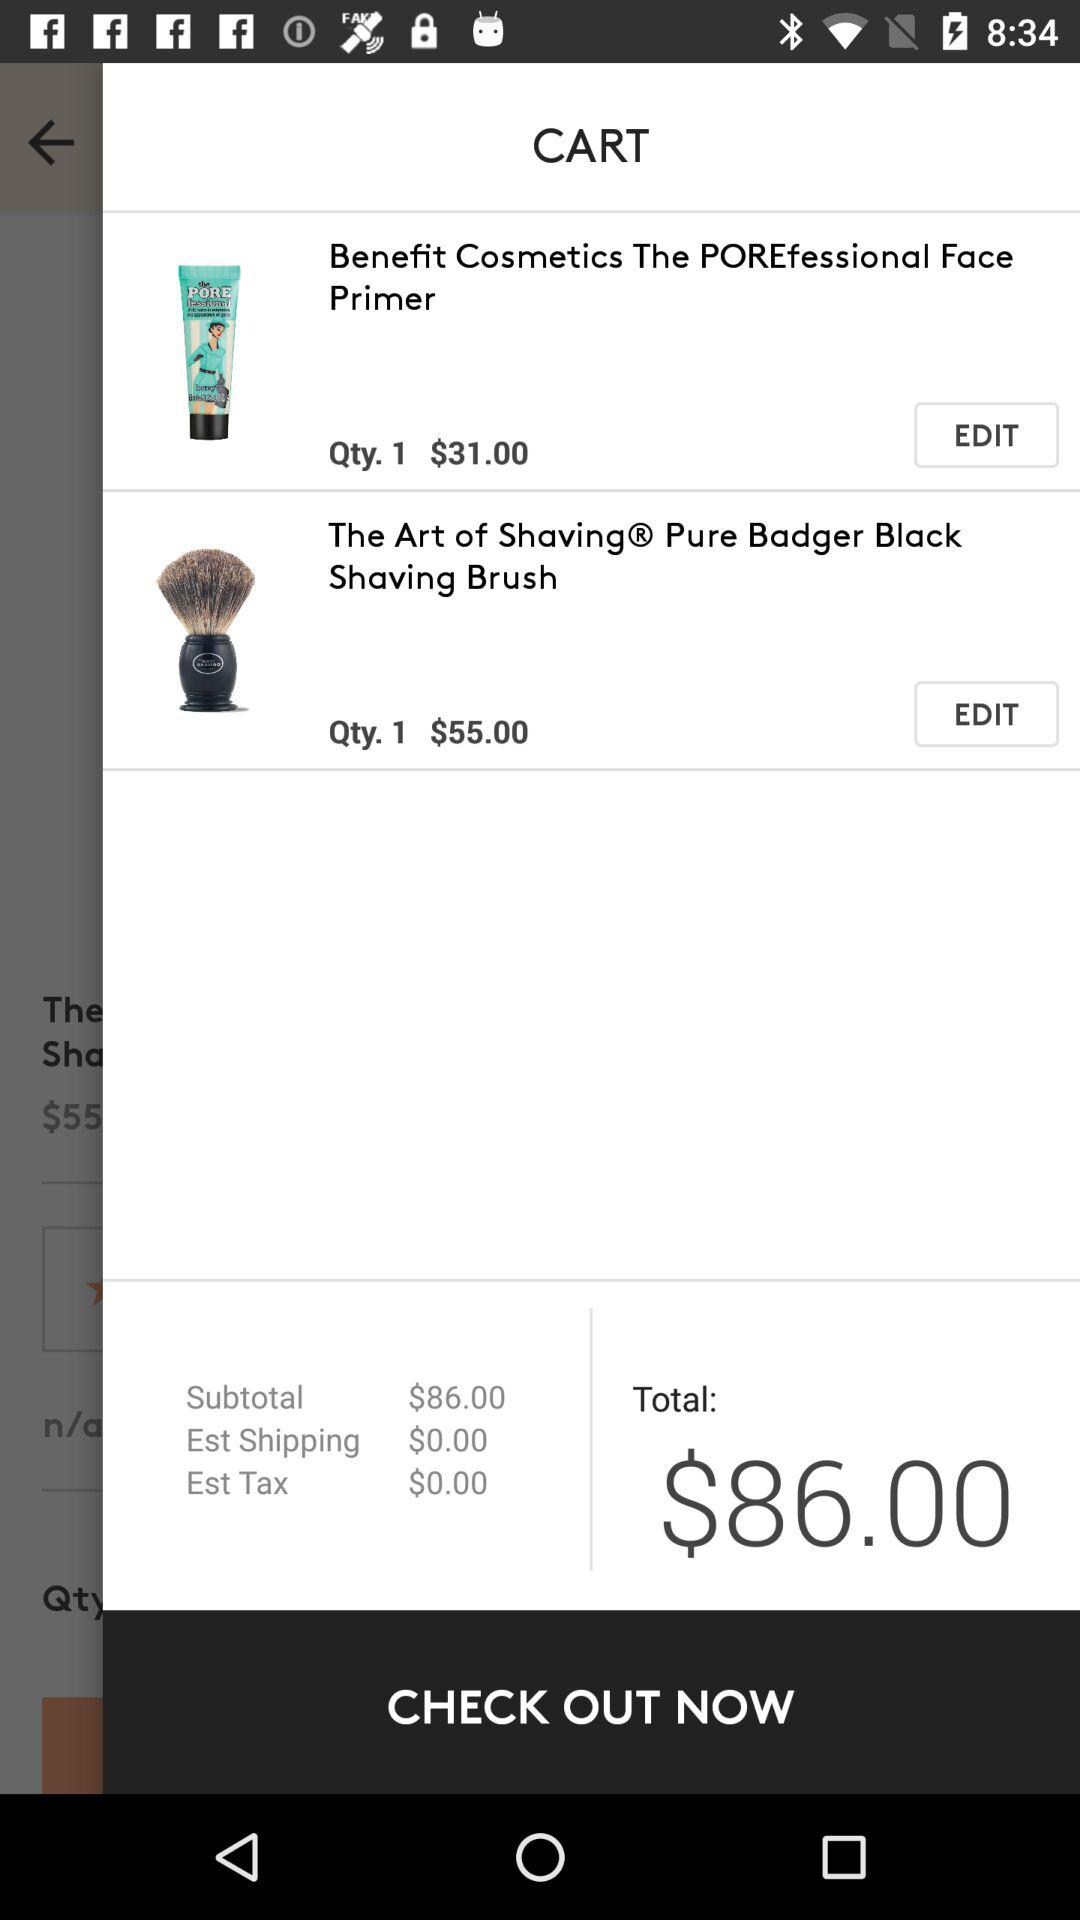What is the total amount? The total amount is $86.00. 